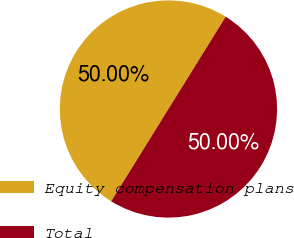Convert chart. <chart><loc_0><loc_0><loc_500><loc_500><pie_chart><fcel>Equity compensation plans<fcel>Total<nl><fcel>50.0%<fcel>50.0%<nl></chart> 